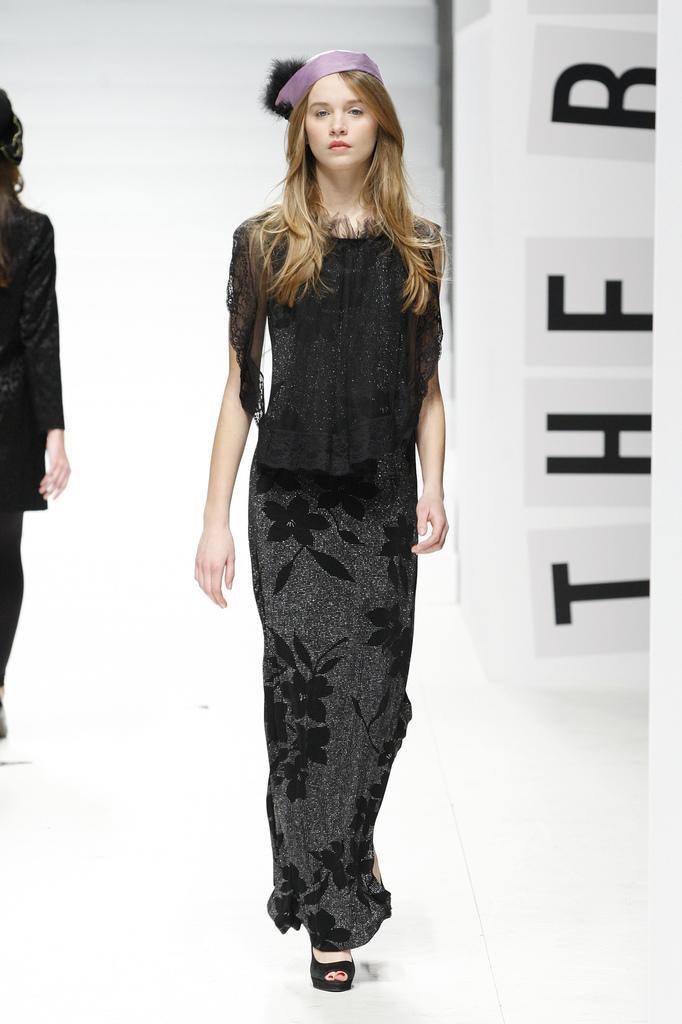Could you give a brief overview of what you see in this image? In this image I can see a woman wearing black color dress is standing on the white colored surface. In the background I can see another woman wearing black colored dress and the white colored wall. 